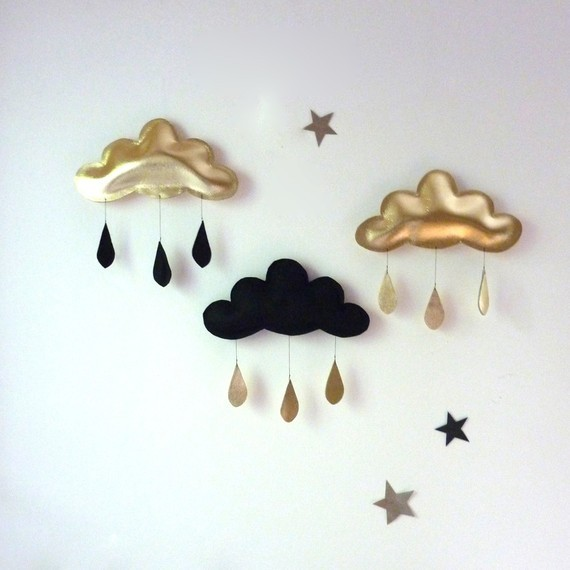Considering the symmetrical color scheme and the arrangement of the clouds and stars, what could be the significance or symbolism behind the alternating colors of the clouds and their respective raindrops? The alternating colors of the clouds and raindrops in this image could be interpreted as an artist's exploration of balance and interconnectedness. Specifically, the gold clouds shedding dark raindrops, contrasted with the solitary black cloud releasing gold ones, evoke a message that elements commonly perceived as contrasting – light and dark, good and bad – are inherently linked and dependent on one another. This is visually reminiscent of the yin and yang symbol, which represents the concept that opposing forces are interconnected in the natural world. Additionally, this artistic depiction might suggest that beauty and positivity can emerge from dark times, just as challenges and hardships can exist in periods of prosperity. The stars scattered around the clouds could add to this symbolism by representing hope or guidance amidst the contrasting themes expressed by the clouds and raindrops. 